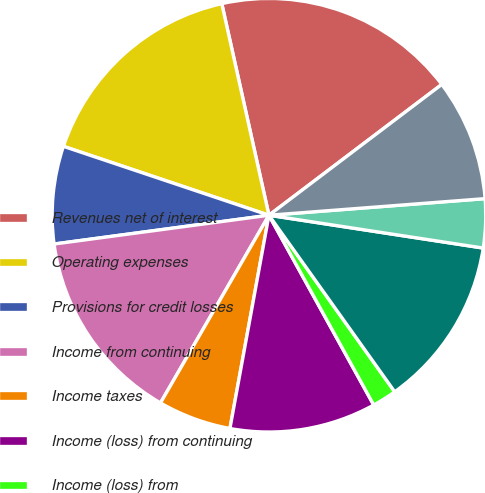<chart> <loc_0><loc_0><loc_500><loc_500><pie_chart><fcel>Revenues net of interest<fcel>Operating expenses<fcel>Provisions for credit losses<fcel>Income from continuing<fcel>Income taxes<fcel>Income (loss) from continuing<fcel>Income (loss) from<fcel>Net income before attribution<fcel>Noncontrolling interests<fcel>Citigroup's net income (loss)<nl><fcel>18.18%<fcel>16.36%<fcel>7.27%<fcel>14.54%<fcel>5.46%<fcel>10.91%<fcel>1.82%<fcel>12.73%<fcel>3.64%<fcel>9.09%<nl></chart> 